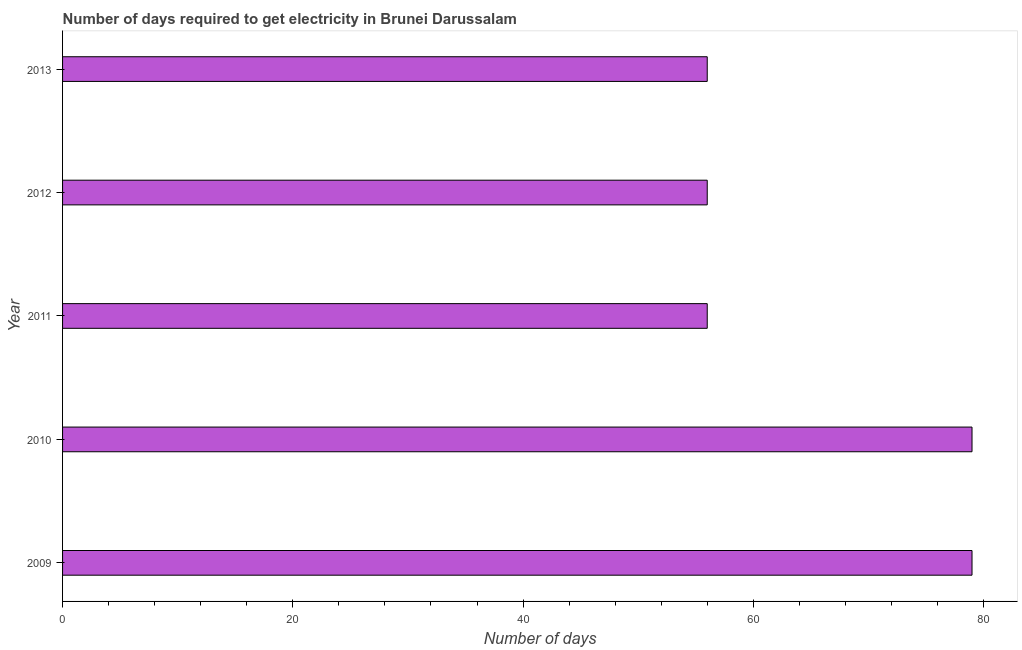Does the graph contain grids?
Ensure brevity in your answer.  No. What is the title of the graph?
Provide a succinct answer. Number of days required to get electricity in Brunei Darussalam. What is the label or title of the X-axis?
Your response must be concise. Number of days. What is the label or title of the Y-axis?
Give a very brief answer. Year. Across all years, what is the maximum time to get electricity?
Your answer should be very brief. 79. In which year was the time to get electricity minimum?
Your answer should be very brief. 2011. What is the sum of the time to get electricity?
Provide a short and direct response. 326. What is the difference between the time to get electricity in 2010 and 2013?
Your answer should be compact. 23. What is the median time to get electricity?
Offer a terse response. 56. In how many years, is the time to get electricity greater than 12 ?
Offer a terse response. 5. Do a majority of the years between 2009 and 2013 (inclusive) have time to get electricity greater than 72 ?
Offer a very short reply. No. What is the ratio of the time to get electricity in 2010 to that in 2013?
Provide a short and direct response. 1.41. Is the time to get electricity in 2010 less than that in 2013?
Your answer should be compact. No. Is the difference between the time to get electricity in 2009 and 2011 greater than the difference between any two years?
Offer a terse response. Yes. What is the difference between the highest and the second highest time to get electricity?
Ensure brevity in your answer.  0. Is the sum of the time to get electricity in 2009 and 2010 greater than the maximum time to get electricity across all years?
Offer a very short reply. Yes. What is the difference between the highest and the lowest time to get electricity?
Offer a terse response. 23. How many bars are there?
Keep it short and to the point. 5. How many years are there in the graph?
Make the answer very short. 5. What is the Number of days in 2009?
Your response must be concise. 79. What is the Number of days in 2010?
Provide a short and direct response. 79. What is the Number of days of 2013?
Your answer should be compact. 56. What is the difference between the Number of days in 2009 and 2010?
Provide a short and direct response. 0. What is the difference between the Number of days in 2009 and 2012?
Your answer should be very brief. 23. What is the difference between the Number of days in 2009 and 2013?
Ensure brevity in your answer.  23. What is the difference between the Number of days in 2010 and 2012?
Give a very brief answer. 23. What is the difference between the Number of days in 2010 and 2013?
Your response must be concise. 23. What is the difference between the Number of days in 2011 and 2012?
Provide a short and direct response. 0. What is the difference between the Number of days in 2011 and 2013?
Provide a succinct answer. 0. What is the ratio of the Number of days in 2009 to that in 2011?
Offer a terse response. 1.41. What is the ratio of the Number of days in 2009 to that in 2012?
Offer a very short reply. 1.41. What is the ratio of the Number of days in 2009 to that in 2013?
Provide a succinct answer. 1.41. What is the ratio of the Number of days in 2010 to that in 2011?
Provide a short and direct response. 1.41. What is the ratio of the Number of days in 2010 to that in 2012?
Provide a succinct answer. 1.41. What is the ratio of the Number of days in 2010 to that in 2013?
Make the answer very short. 1.41. What is the ratio of the Number of days in 2011 to that in 2012?
Offer a terse response. 1. 